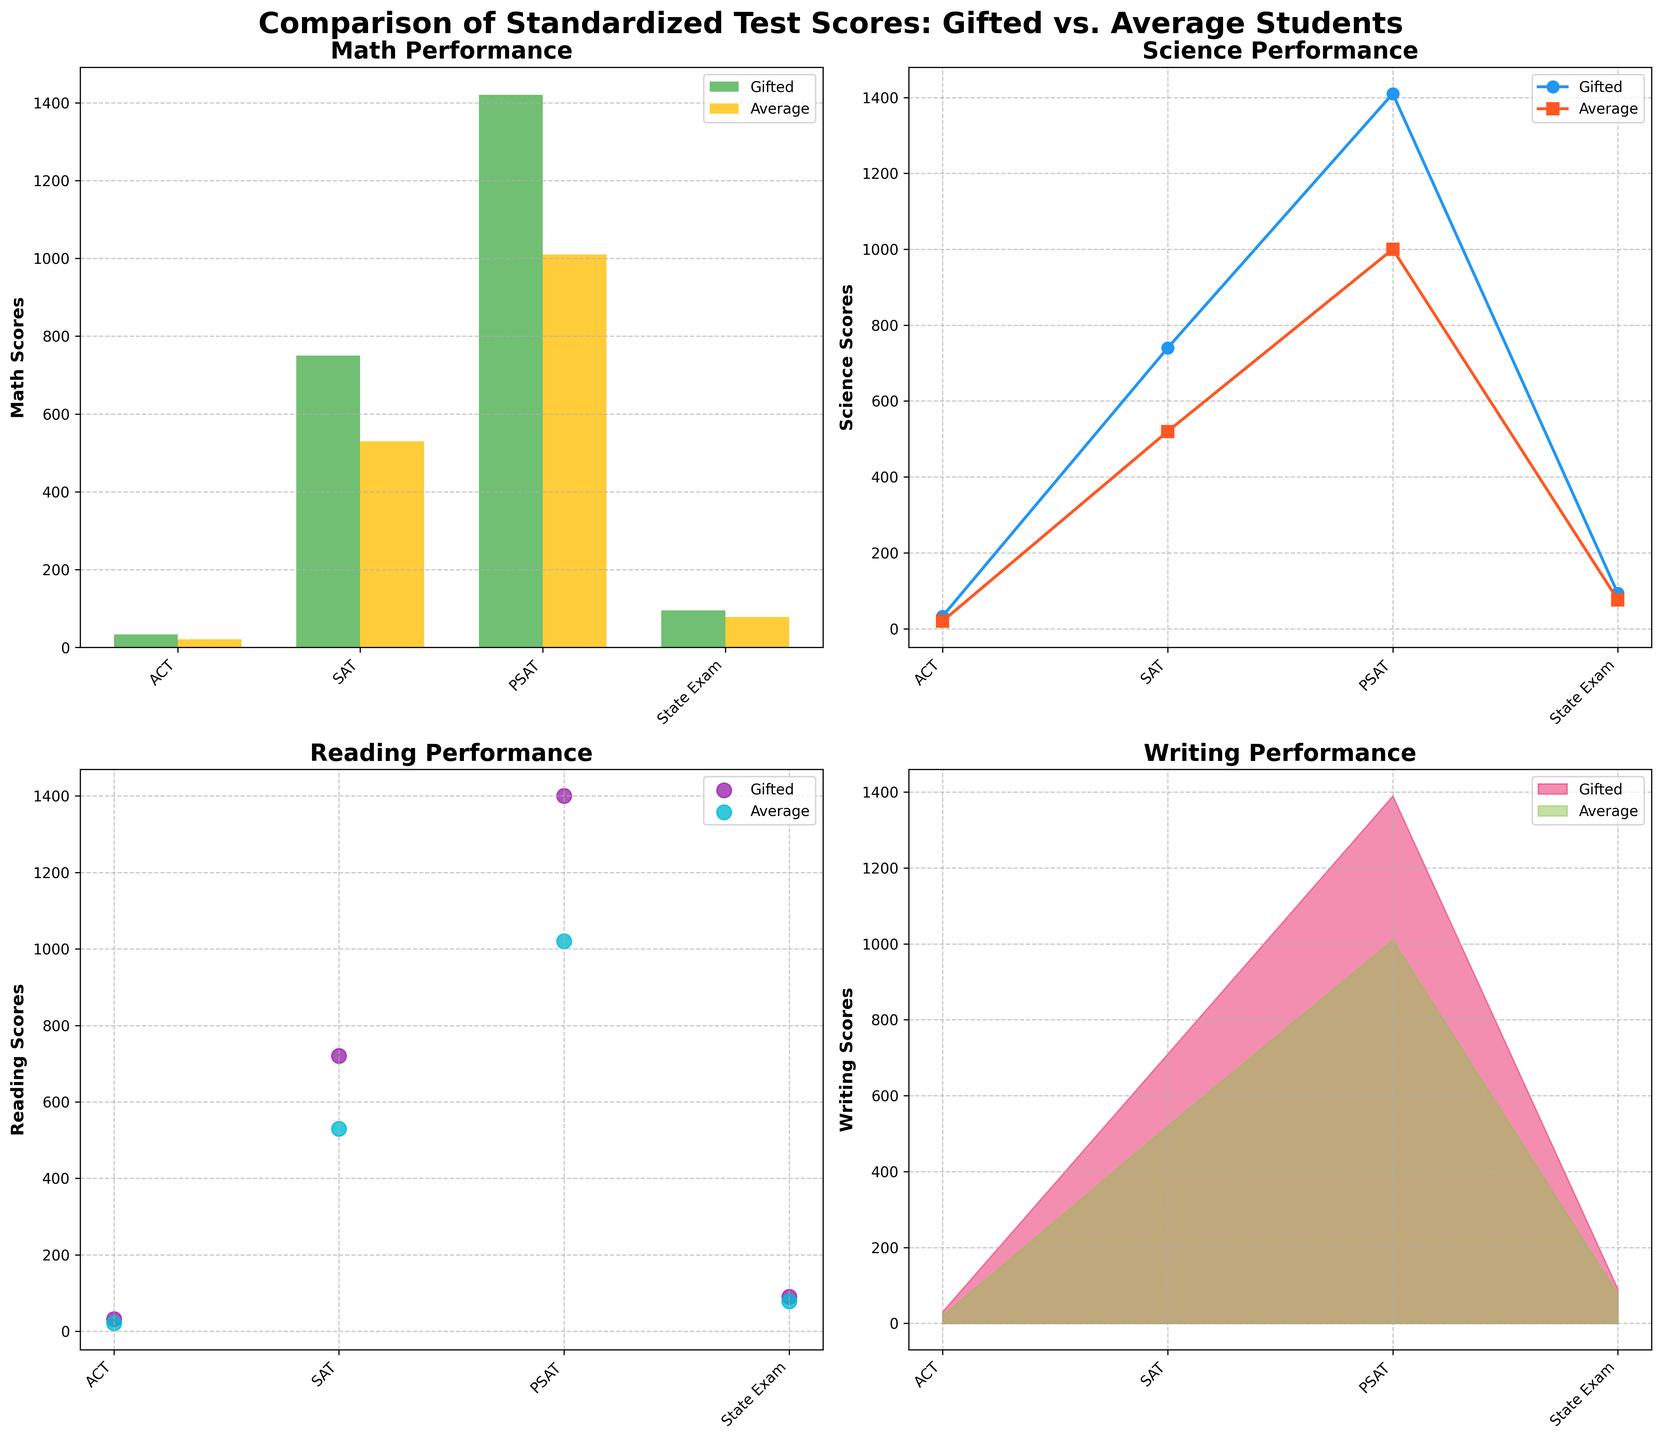Which subject shows the smallest score difference between gifted and average students on the ACT? The bar plot for Math shows the scores for ACT are 34 (Gifted) and 21 (Average), Science 33 and 20, Reading 32 and 21, Writing 31 and 20. Therefore, Reading with a difference of 11.
Answer: Reading What is the average score for gifted students in Science across all the standardized tests? The scores for gifted students in Science are: ACT (33), SAT (740), PSAT (1410), State Exam (93). Calculating the average: (33 + 740 + 1410 + 93) / 4 = 569.
Answer: 569 Which test has the biggest gap in Writing scores between gifted and average students? The stacked area plot for Writing shows the scores for ACT are 31 (Gifted) and 20 (Average), SAT 710 and 520, PSAT 1390 and 1010, State Exam 90 and 77. The gap for PSAT is the highest at 380.
Answer: PSAT What is the trend in Math scores between gifted and average students across different standardized tests? The bar plot for Math reveals consistent higher scores for gifted students in all tests: ACT, SAT, PSAT, and State Exam.
Answer: Gifted students consistently score higher What is the overall trend in Science scores for average students as seen in the line plot? The line plot for Science suggests that average students' scores are progressively improving from ACT (20), SAT (520), PSAT (1000), to State Exam (76).
Answer: Varies across exams Which subject shows the highest score for gifted students on the PSAT? The scatter plot for Reading shows the gifted students' scores for PSAT are: Math (1420), Science (1410), Reading (1400), Writing (1390). Math has the highest score.
Answer: Math How do gifted students' scores in Writing compare between the SAT and State Exam? The stacked area plot indicates the scores are 710 (SAT) and 90 (State Exam). The SAT score is significantly higher.
Answer: SAT is higher Are the gifted students' Science scores always higher than the average students' Science scores for each test? The line plot for Science shows that in every standardized test (ACT, SAT, PSAT, State Exam), gifted students score higher than average students.
Answer: Yes How much higher is the gifted students' Math score on the SAT compared to the State Exam? The bar plot shows SAT scores for gifted students in Math are 750, and for the State Exam 95. The difference is 750 - 95 = 655.
Answer: 655 Which subject shows the closest scores between gifted and average students on the State Exam? Reviewing the plots: Math (95, 78), Science (93, 76), Reading (91, 79), Writing (90, 77). Math shows the smallest difference.
Answer: Math (Difference = 17) 